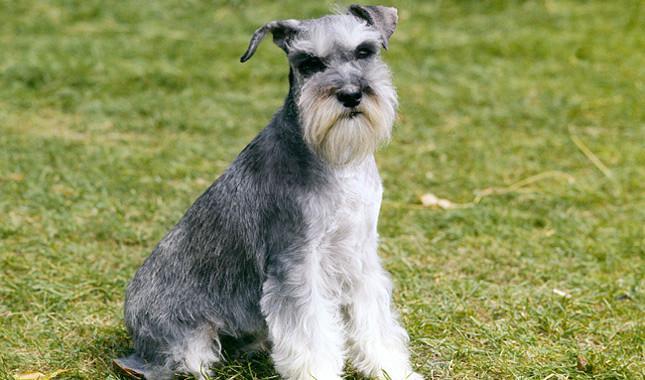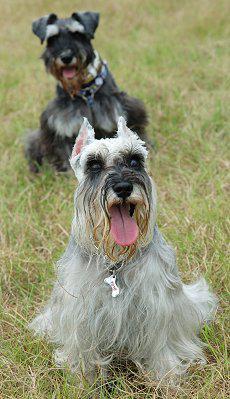The first image is the image on the left, the second image is the image on the right. For the images shown, is this caption "The left image shows a schnauzer sitting upright." true? Answer yes or no. Yes. 